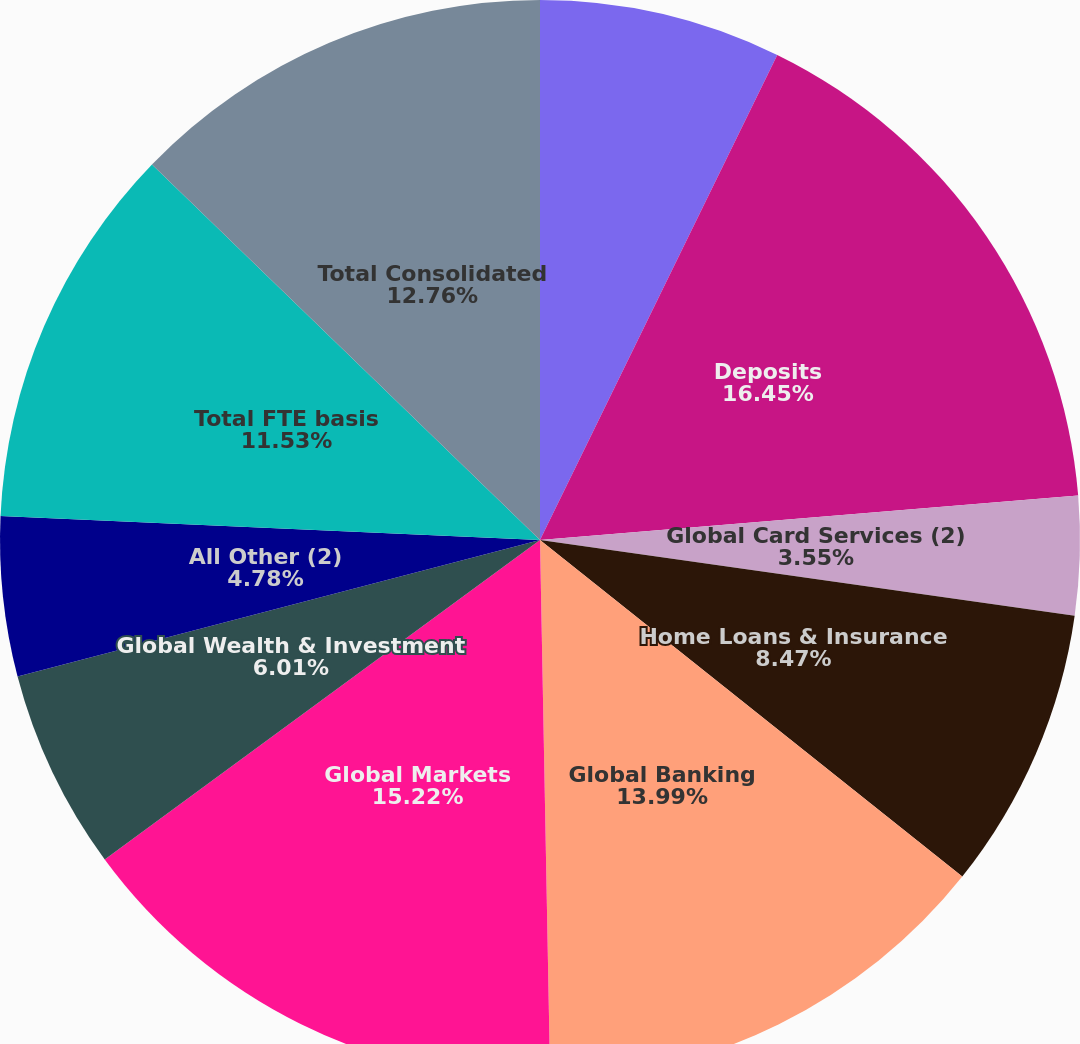Convert chart to OTSL. <chart><loc_0><loc_0><loc_500><loc_500><pie_chart><fcel>(Dollars in millions)<fcel>Deposits<fcel>Global Card Services (2)<fcel>Home Loans & Insurance<fcel>Global Banking<fcel>Global Markets<fcel>Global Wealth & Investment<fcel>All Other (2)<fcel>Total FTE basis<fcel>Total Consolidated<nl><fcel>7.24%<fcel>16.45%<fcel>3.55%<fcel>8.47%<fcel>13.99%<fcel>15.22%<fcel>6.01%<fcel>4.78%<fcel>11.53%<fcel>12.76%<nl></chart> 